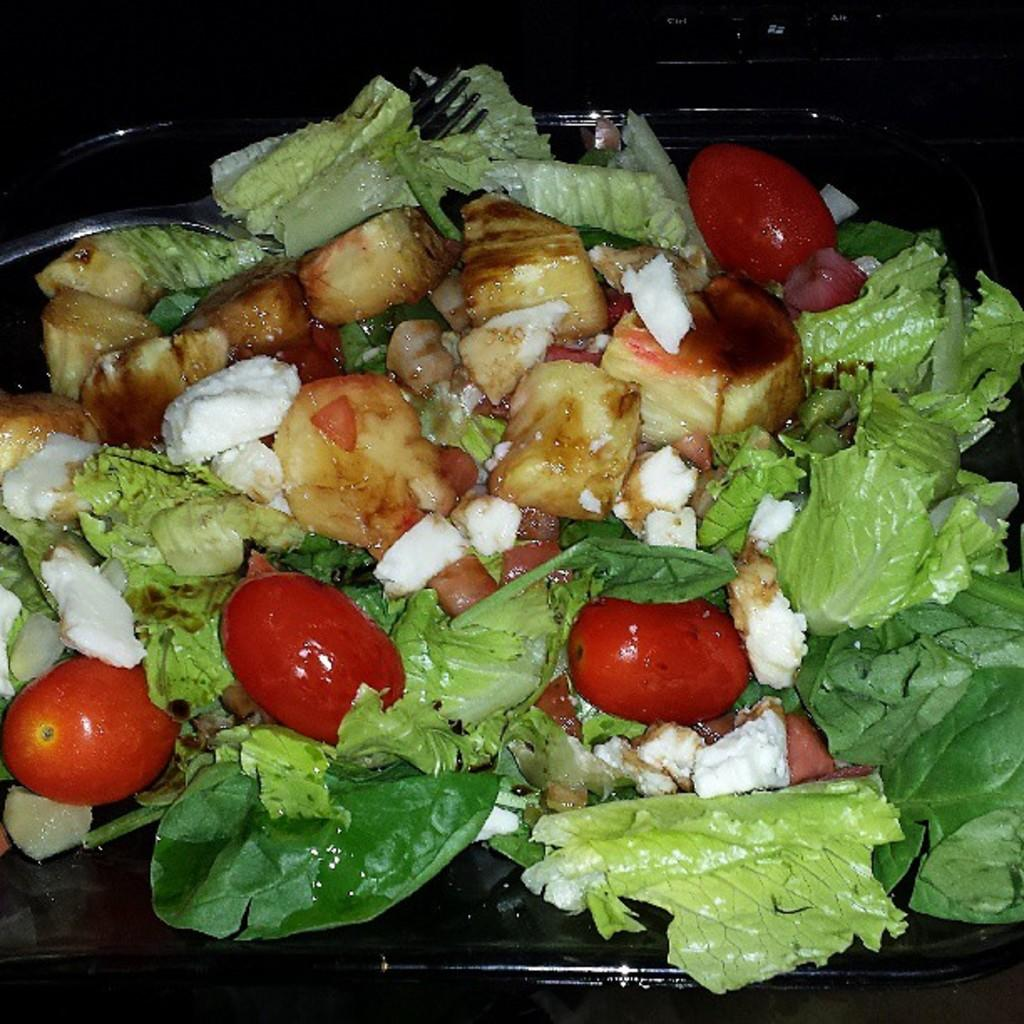What is the color of the tray in the image? The tray in the image is black. What items are on the tray? The tray contains leaves, tomatoes, and other food items. Can you describe the utensil in the image? There is a fork in the image. What type of flowers can be seen on the tray in the image? There are no flowers present on the tray in the image; it contains leaves, tomatoes, and other food items. What activity is the button performing in the image? There is no button present in the image, so it cannot be performing any activity. 